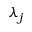Convert formula to latex. <formula><loc_0><loc_0><loc_500><loc_500>\lambda _ { j }</formula> 